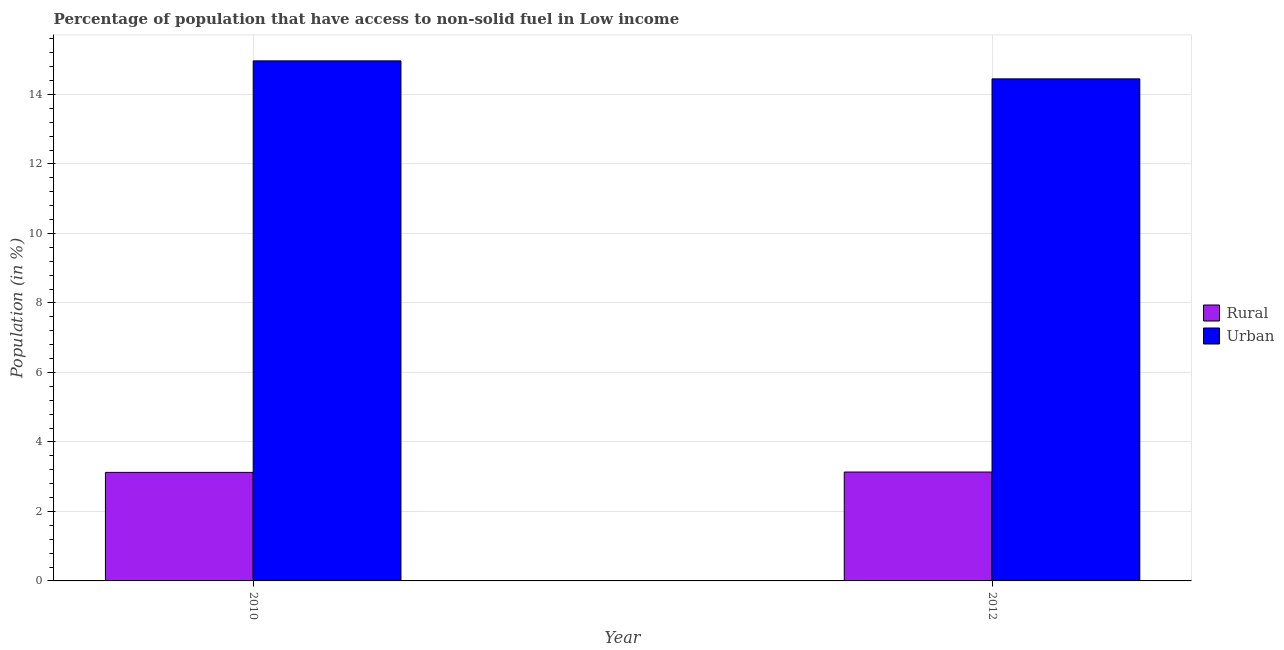How many different coloured bars are there?
Your answer should be compact. 2. What is the label of the 2nd group of bars from the left?
Keep it short and to the point. 2012. In how many cases, is the number of bars for a given year not equal to the number of legend labels?
Ensure brevity in your answer.  0. What is the urban population in 2012?
Make the answer very short. 14.45. Across all years, what is the maximum urban population?
Ensure brevity in your answer.  14.97. Across all years, what is the minimum rural population?
Provide a short and direct response. 3.12. In which year was the rural population maximum?
Keep it short and to the point. 2012. What is the total urban population in the graph?
Keep it short and to the point. 29.42. What is the difference between the urban population in 2010 and that in 2012?
Provide a succinct answer. 0.52. What is the difference between the urban population in 2012 and the rural population in 2010?
Your answer should be very brief. -0.52. What is the average urban population per year?
Your answer should be very brief. 14.71. In the year 2012, what is the difference between the urban population and rural population?
Your answer should be compact. 0. What is the ratio of the urban population in 2010 to that in 2012?
Your answer should be compact. 1.04. Is the urban population in 2010 less than that in 2012?
Offer a very short reply. No. What does the 2nd bar from the left in 2012 represents?
Provide a short and direct response. Urban. What does the 1st bar from the right in 2010 represents?
Provide a short and direct response. Urban. How many bars are there?
Provide a succinct answer. 4. Are all the bars in the graph horizontal?
Give a very brief answer. No. How many years are there in the graph?
Give a very brief answer. 2. What is the difference between two consecutive major ticks on the Y-axis?
Ensure brevity in your answer.  2. Does the graph contain any zero values?
Keep it short and to the point. No. How many legend labels are there?
Give a very brief answer. 2. What is the title of the graph?
Your answer should be compact. Percentage of population that have access to non-solid fuel in Low income. What is the label or title of the X-axis?
Ensure brevity in your answer.  Year. What is the label or title of the Y-axis?
Your response must be concise. Population (in %). What is the Population (in %) in Rural in 2010?
Give a very brief answer. 3.12. What is the Population (in %) in Urban in 2010?
Provide a short and direct response. 14.97. What is the Population (in %) in Rural in 2012?
Ensure brevity in your answer.  3.13. What is the Population (in %) of Urban in 2012?
Make the answer very short. 14.45. Across all years, what is the maximum Population (in %) of Rural?
Offer a very short reply. 3.13. Across all years, what is the maximum Population (in %) of Urban?
Provide a short and direct response. 14.97. Across all years, what is the minimum Population (in %) in Rural?
Your answer should be compact. 3.12. Across all years, what is the minimum Population (in %) of Urban?
Provide a succinct answer. 14.45. What is the total Population (in %) in Rural in the graph?
Offer a terse response. 6.26. What is the total Population (in %) in Urban in the graph?
Ensure brevity in your answer.  29.42. What is the difference between the Population (in %) of Rural in 2010 and that in 2012?
Your answer should be compact. -0.01. What is the difference between the Population (in %) of Urban in 2010 and that in 2012?
Make the answer very short. 0.52. What is the difference between the Population (in %) of Rural in 2010 and the Population (in %) of Urban in 2012?
Offer a very short reply. -11.33. What is the average Population (in %) of Rural per year?
Your answer should be compact. 3.13. What is the average Population (in %) in Urban per year?
Your answer should be very brief. 14.71. In the year 2010, what is the difference between the Population (in %) of Rural and Population (in %) of Urban?
Make the answer very short. -11.84. In the year 2012, what is the difference between the Population (in %) in Rural and Population (in %) in Urban?
Offer a very short reply. -11.32. What is the ratio of the Population (in %) in Urban in 2010 to that in 2012?
Keep it short and to the point. 1.04. What is the difference between the highest and the second highest Population (in %) in Rural?
Ensure brevity in your answer.  0.01. What is the difference between the highest and the second highest Population (in %) of Urban?
Offer a very short reply. 0.52. What is the difference between the highest and the lowest Population (in %) of Rural?
Keep it short and to the point. 0.01. What is the difference between the highest and the lowest Population (in %) in Urban?
Ensure brevity in your answer.  0.52. 